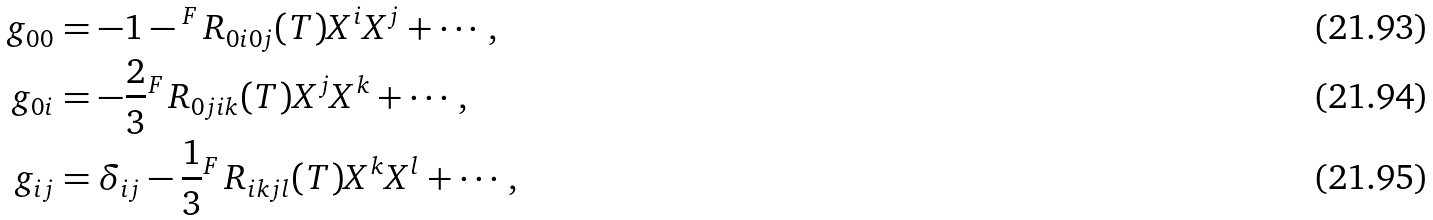<formula> <loc_0><loc_0><loc_500><loc_500>g _ { 0 0 } & = - 1 - { ^ { F } \, R _ { 0 i 0 j } } ( T ) X ^ { i } X ^ { j } + \cdots , \\ g _ { 0 i } & = - \frac { 2 } { 3 } { ^ { F } \, R _ { 0 j i k } } ( T ) X ^ { j } X ^ { k } + \cdots , \\ g _ { i j } & = \delta _ { i j } - \frac { 1 } { 3 } { ^ { F } \, R _ { i k j l } } ( T ) X ^ { k } X ^ { l } + \cdots ,</formula> 